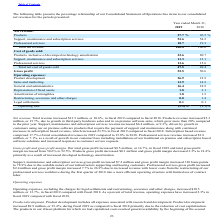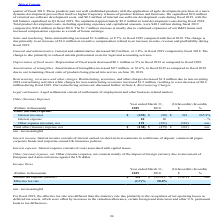According to Agilysys's financial document, What was the increase in total revenue? $13.5 million, or 10.6%. The document states: "Net revenue. Total revenue increased $13.5 million, or 10.6%, in fiscal 2019 compared to fiscal 2018. Products revenue increased $5.3 million, or 15.7..." Also, What was the increase in the support, maintenance and subscription? $6.4 million, or 9.3%. The document states: "enance and subscription services revenue increased $6.4 million, or 9.3%, driven by growth in customers using our on premise software products that re..." Also, What was the products expressed as a percentage of Net revenue in 2019? According to the financial document, 27.7%. The relevant text states: "Net revenue: Products 27.7 % 26.5 %..." Also, can you calculate: What was the increase / (decrease) in the percentage of professional services of revenue from 2018 to 2019? Based on the calculation: 18.7 - 19.3, the result is -0.6 (percentage). This is based on the information: "Professional services 18.7 19.3 Professional services 18.7 19.3..." The key data points involved are: 18.7, 19.3. Also, can you calculate: What was total revenue in 2018? To answer this question, I need to perform calculations using the financial data. The calculation is: 13.5/10.6*100, which equals 127.36 (in millions). This is based on the information: "evenue. Total revenue increased $13.5 million, or 10.6%, in fiscal 2019 compared to fiscal 2018. Products revenue increased $5.3 million, or 15.7%, due to Net revenue. Total revenue increased $13.5 mi..." The key data points involved are: 10.6, 13.5. Also, can you calculate: What was the percentage increase / (decrease) in the depreciation of fixed assets as a percentage of operating expenses from 2018 to 2019? Based on the calculation: 1.8 - 2.1, the result is -0.3 (percentage). This is based on the information: "Depreciation of fixed assets 1.8 2.1 Depreciation of fixed assets 1.8 2.1..." The key data points involved are: 1.8, 2.1. 